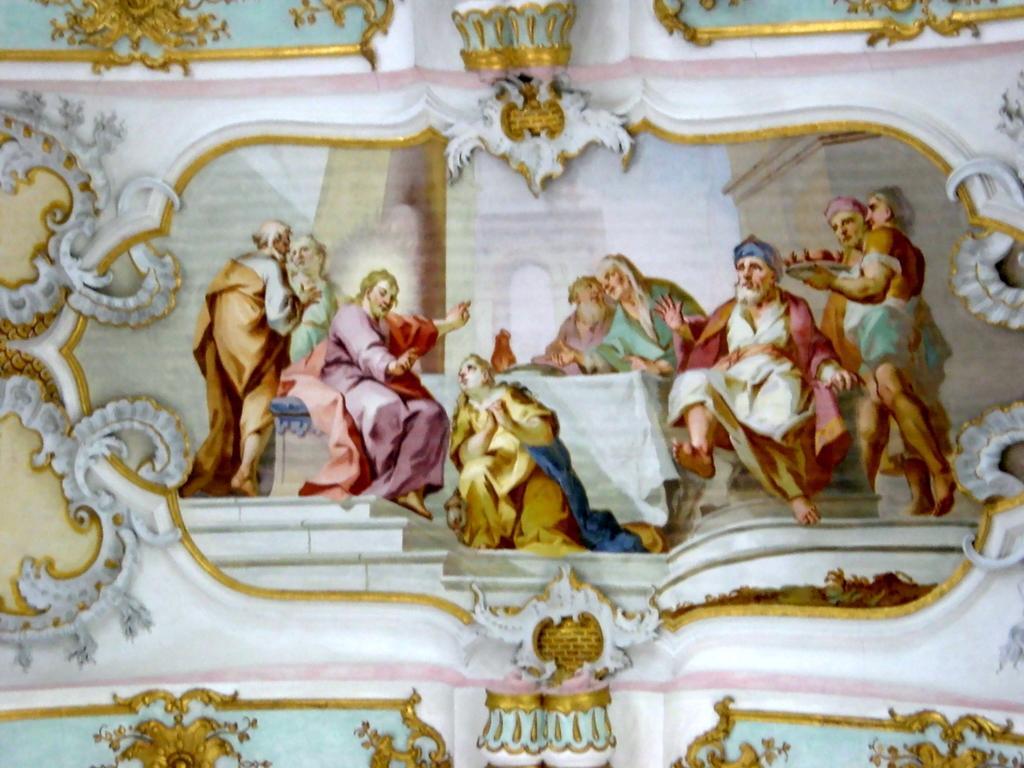Describe this image in one or two sentences. In this image I can see few people with different color dresses. And I can see one person is holding the plate. These people are in the wall. The wall is also colorful. 